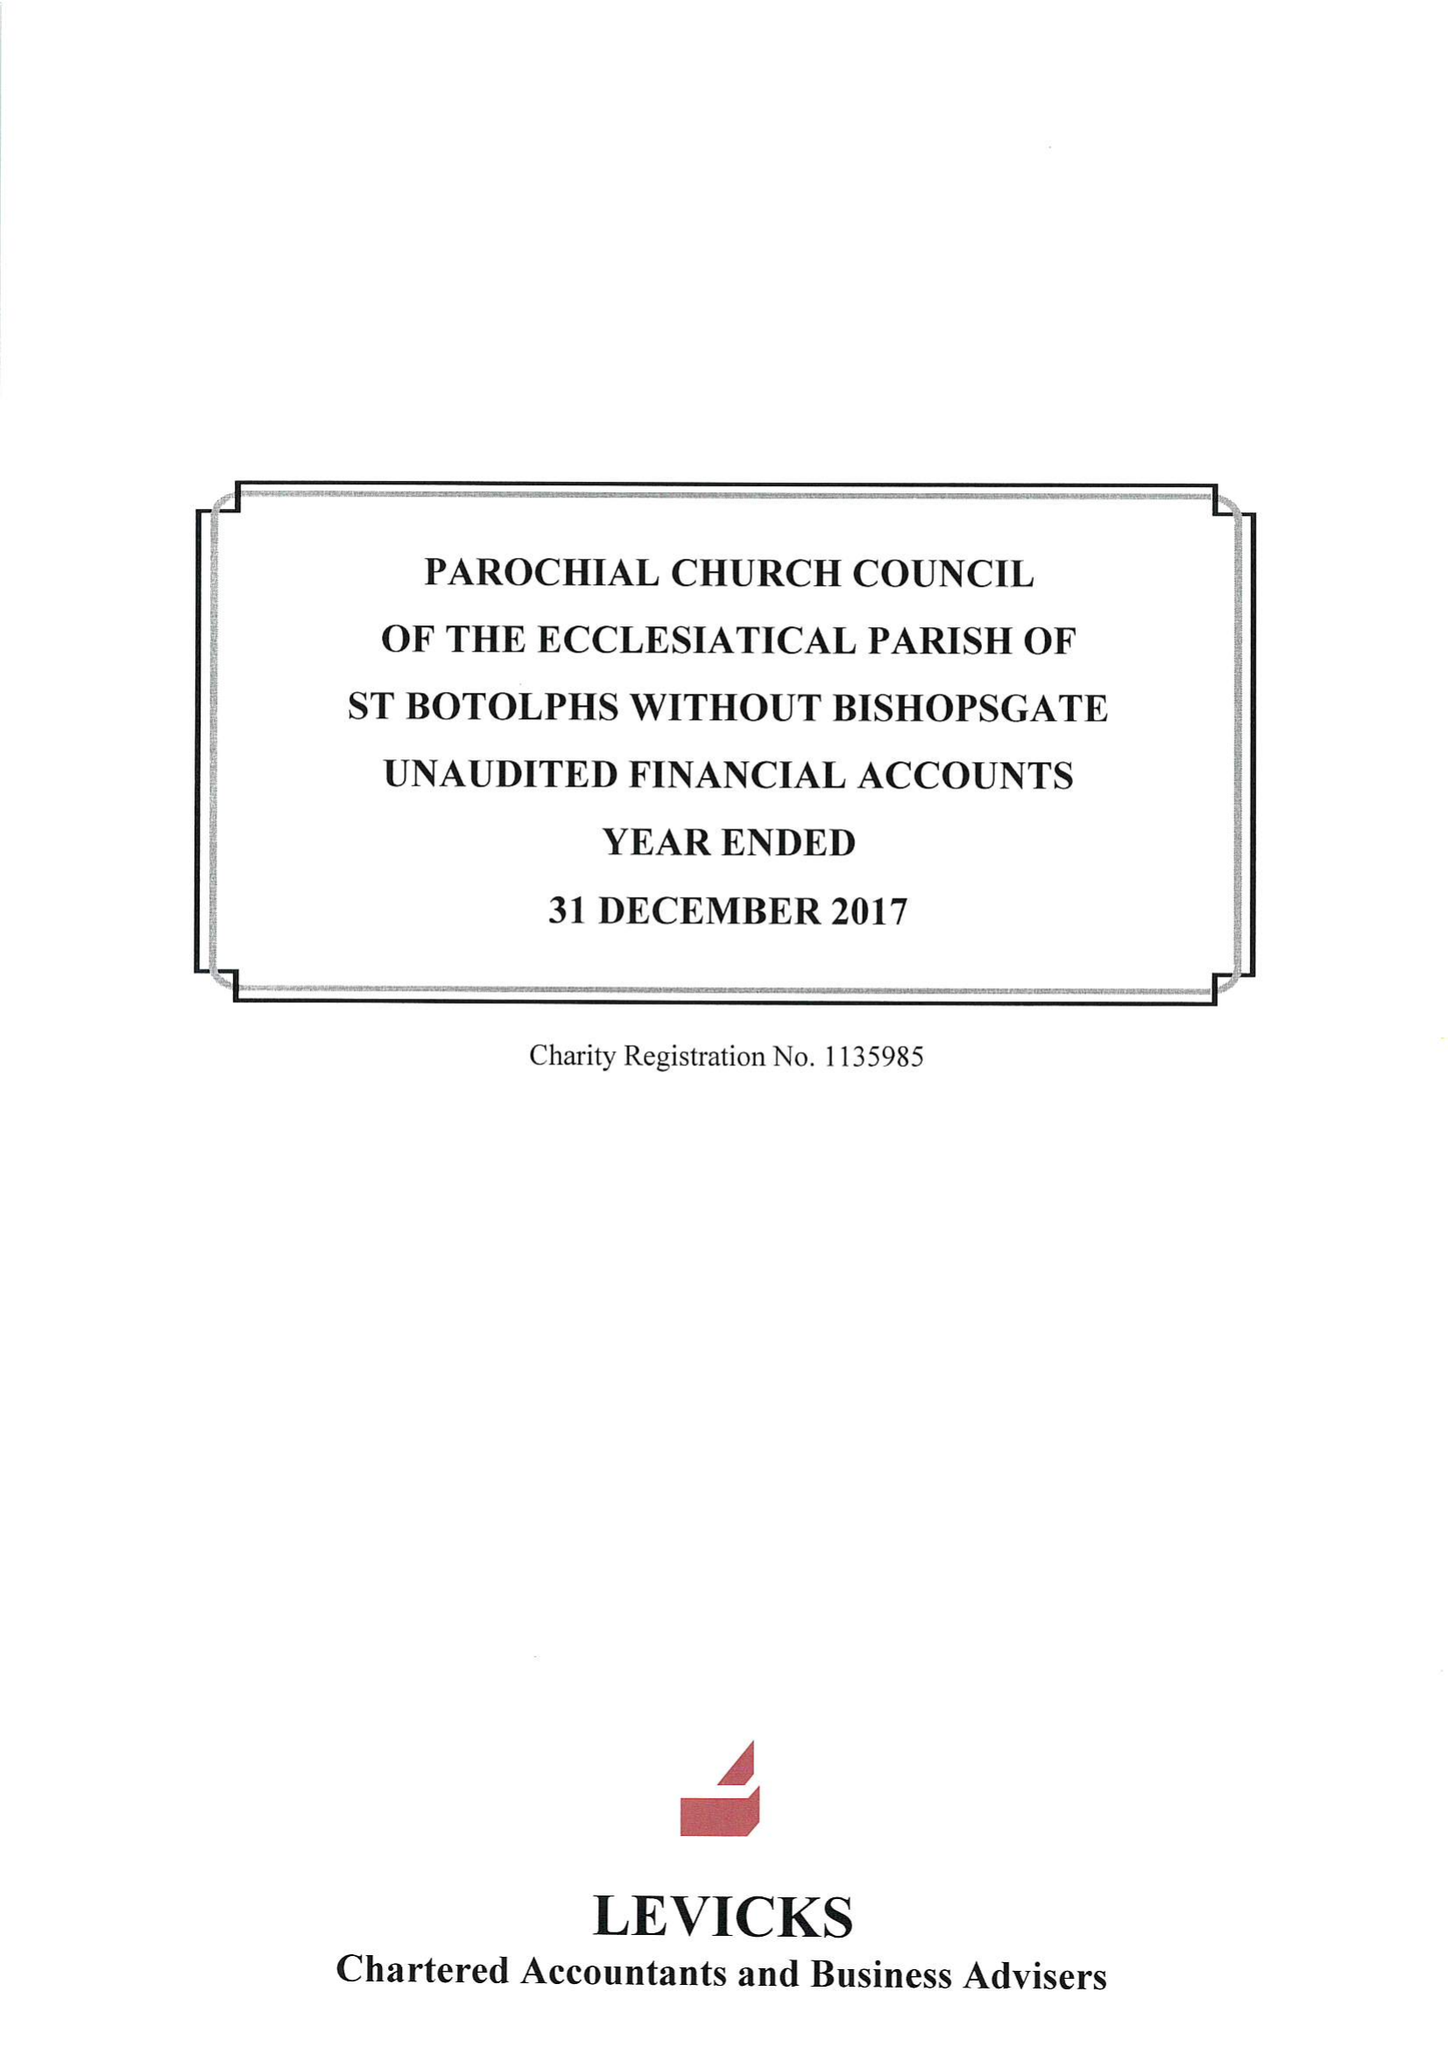What is the value for the spending_annually_in_british_pounds?
Answer the question using a single word or phrase. 360423.00 